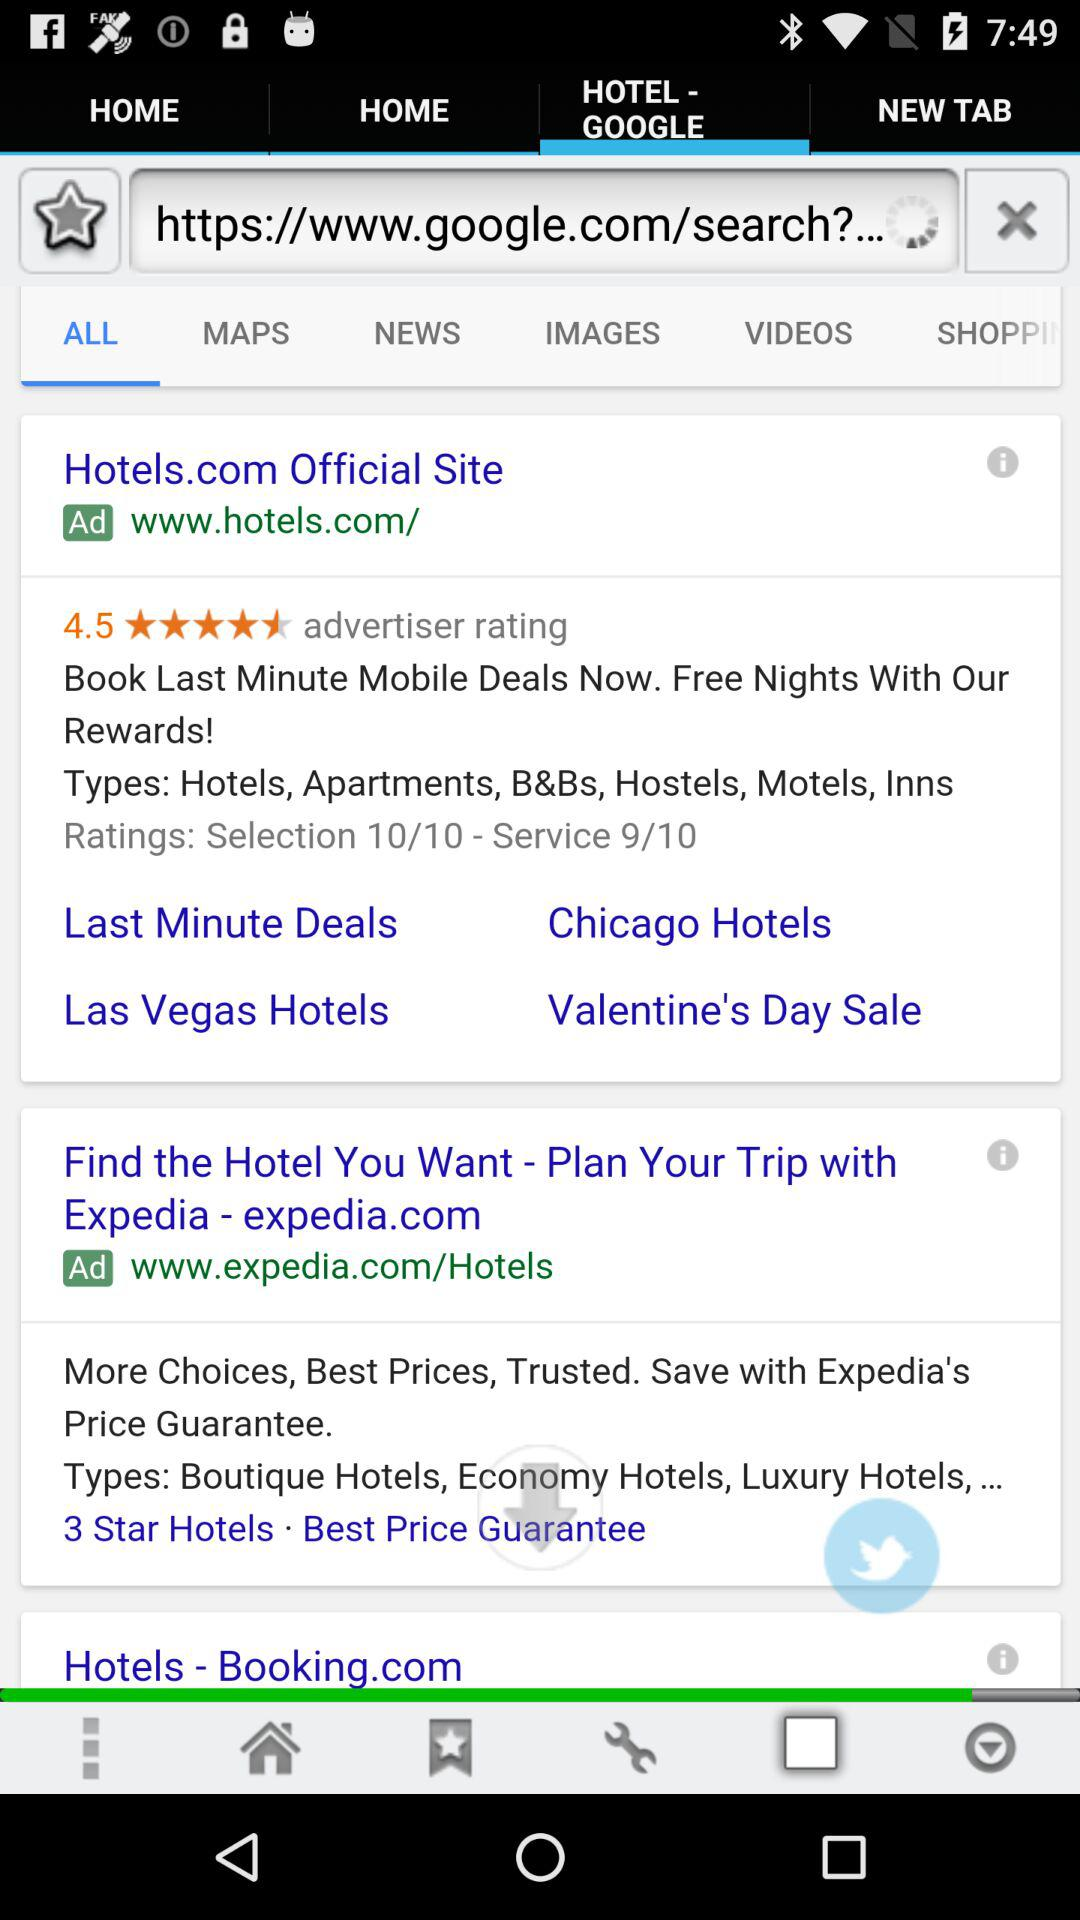Which tab is selected? The selected tabs are "HOTEL - GOOGLE" and "ALL". 